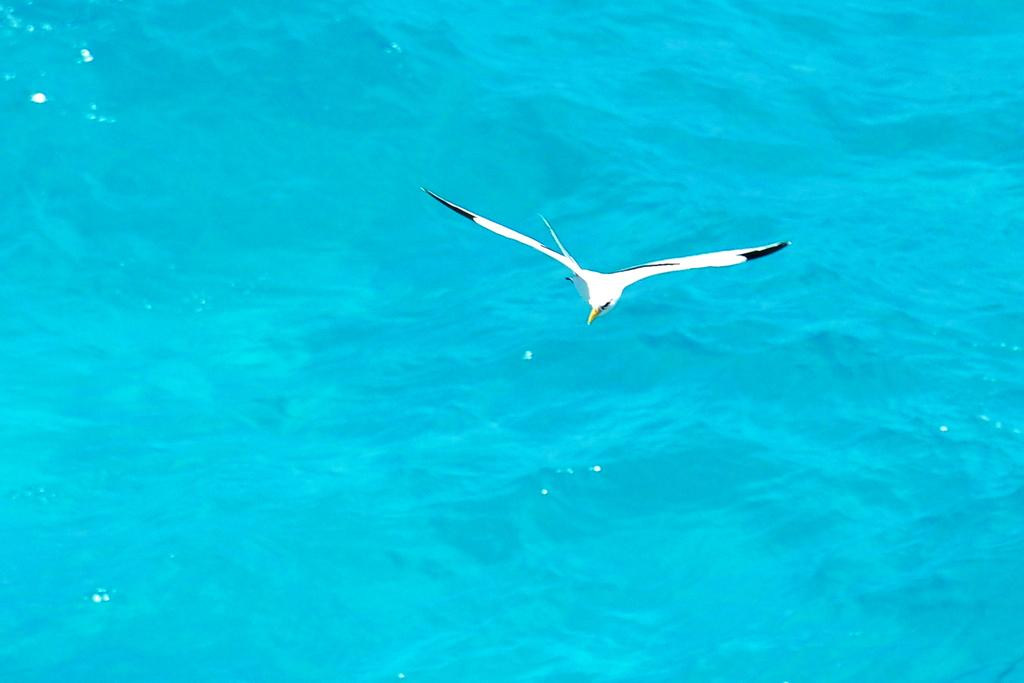What type of animal can be seen in the image? There is a white bird in the image. What is the bird doing in the image? The bird is flying in the image. Where is the bird located in relation to the water? The bird is above the water in the image. What color is the water visible in the image? The water is blue in the image. What type of breakfast is the bird eating in the image? There is no breakfast present in the image, as it features a bird flying above blue water. 